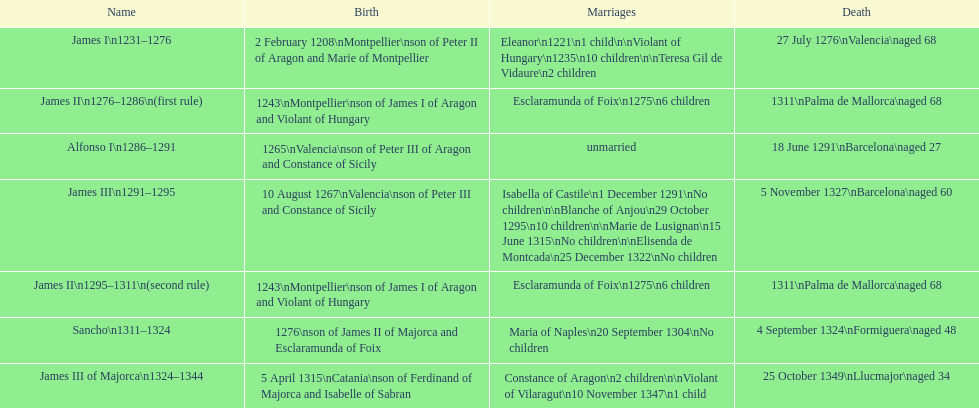What was the total number of marriages james i had? 3. 